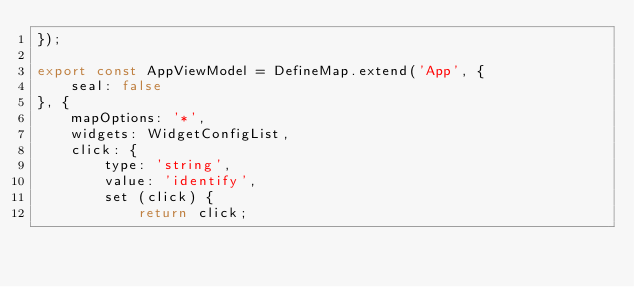<code> <loc_0><loc_0><loc_500><loc_500><_JavaScript_>});

export const AppViewModel = DefineMap.extend('App', {
    seal: false
}, {
    mapOptions: '*',
    widgets: WidgetConfigList,
    click: {
        type: 'string',
        value: 'identify',
        set (click) {
            return click;</code> 